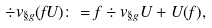<formula> <loc_0><loc_0><loc_500><loc_500>\div v _ { \S g } ( f U ) \colon = f \div v _ { \S g } U + U ( f ) ,</formula> 